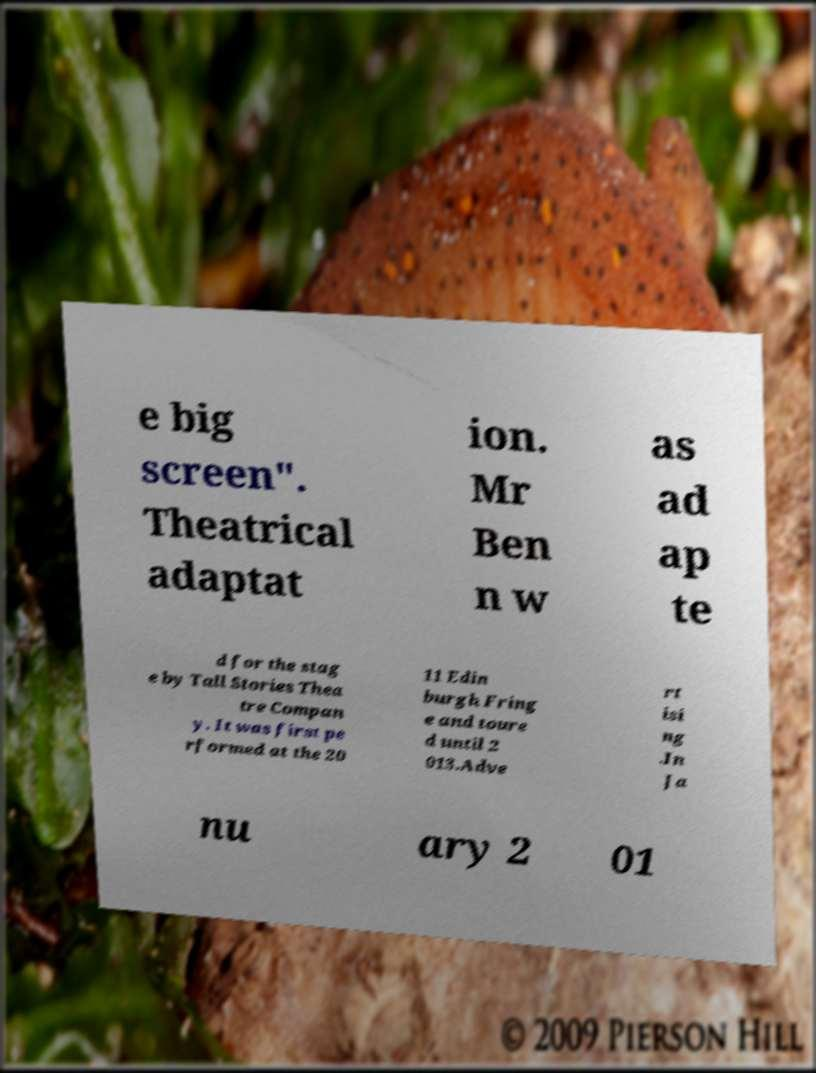Could you extract and type out the text from this image? e big screen". Theatrical adaptat ion. Mr Ben n w as ad ap te d for the stag e by Tall Stories Thea tre Compan y. It was first pe rformed at the 20 11 Edin burgh Fring e and toure d until 2 013.Adve rt isi ng .In Ja nu ary 2 01 